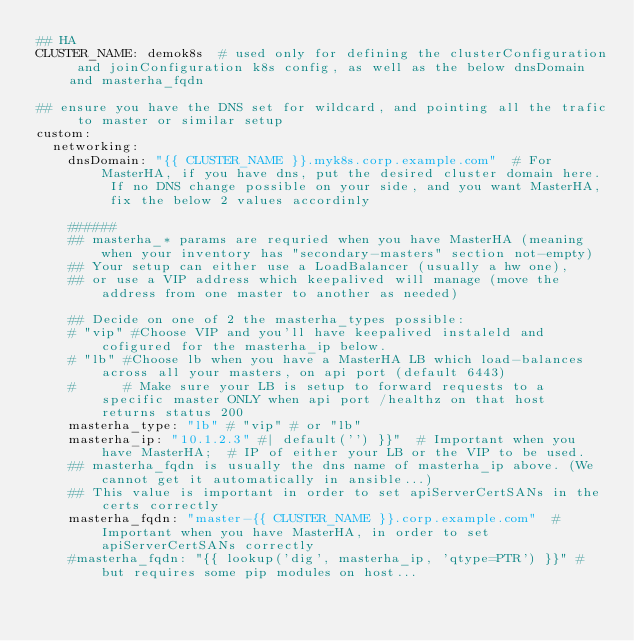Convert code to text. <code><loc_0><loc_0><loc_500><loc_500><_YAML_>## HA
CLUSTER_NAME: demok8s  # used only for defining the clusterConfiguration and joinConfiguration k8s config, as well as the below dnsDomain and masterha_fqdn

## ensure you have the DNS set for wildcard, and pointing all the trafic to master or similar setup
custom:
  networking:
    dnsDomain: "{{ CLUSTER_NAME }}.myk8s.corp.example.com"  # For MasterHA, if you have dns, put the desired cluster domain here. If no DNS change possible on your side, and you want MasterHA, fix the below 2 values accordinly

    ######
    ## masterha_* params are requried when you have MasterHA (meaning when your inventory has "secondary-masters" section not-empty)
    ## Your setup can either use a LoadBalancer (usually a hw one), 
    ## or use a VIP address which keepalived will manage (move the address from one master to another as needed)

    ## Decide on one of 2 the masterha_types possible:
    # "vip" #Choose VIP and you'll have keepalived instaleld and cofigured for the masterha_ip below.
    # "lb" #Choose lb when you have a MasterHA LB which load-balances across all your masters, on api port (default 6443) 
    #      # Make sure your LB is setup to forward requests to a specific master ONLY when api port /healthz on that host returns status 200 
    masterha_type: "lb" # "vip" # or "lb"
    masterha_ip: "10.1.2.3" #| default('') }}"  # Important when you have MasterHA;  # IP of either your LB or the VIP to be used.
    ## masterha_fqdn is usually the dns name of masterha_ip above. (We cannot get it automatically in ansible...)
    ## This value is important in order to set apiServerCertSANs in the certs correctly
    masterha_fqdn: "master-{{ CLUSTER_NAME }}.corp.example.com"  # Important when you have MasterHA, in order to set apiServerCertSANs correctly
    #masterha_fqdn: "{{ lookup('dig', masterha_ip, 'qtype=PTR') }}" # but requires some pip modules on host...
</code> 